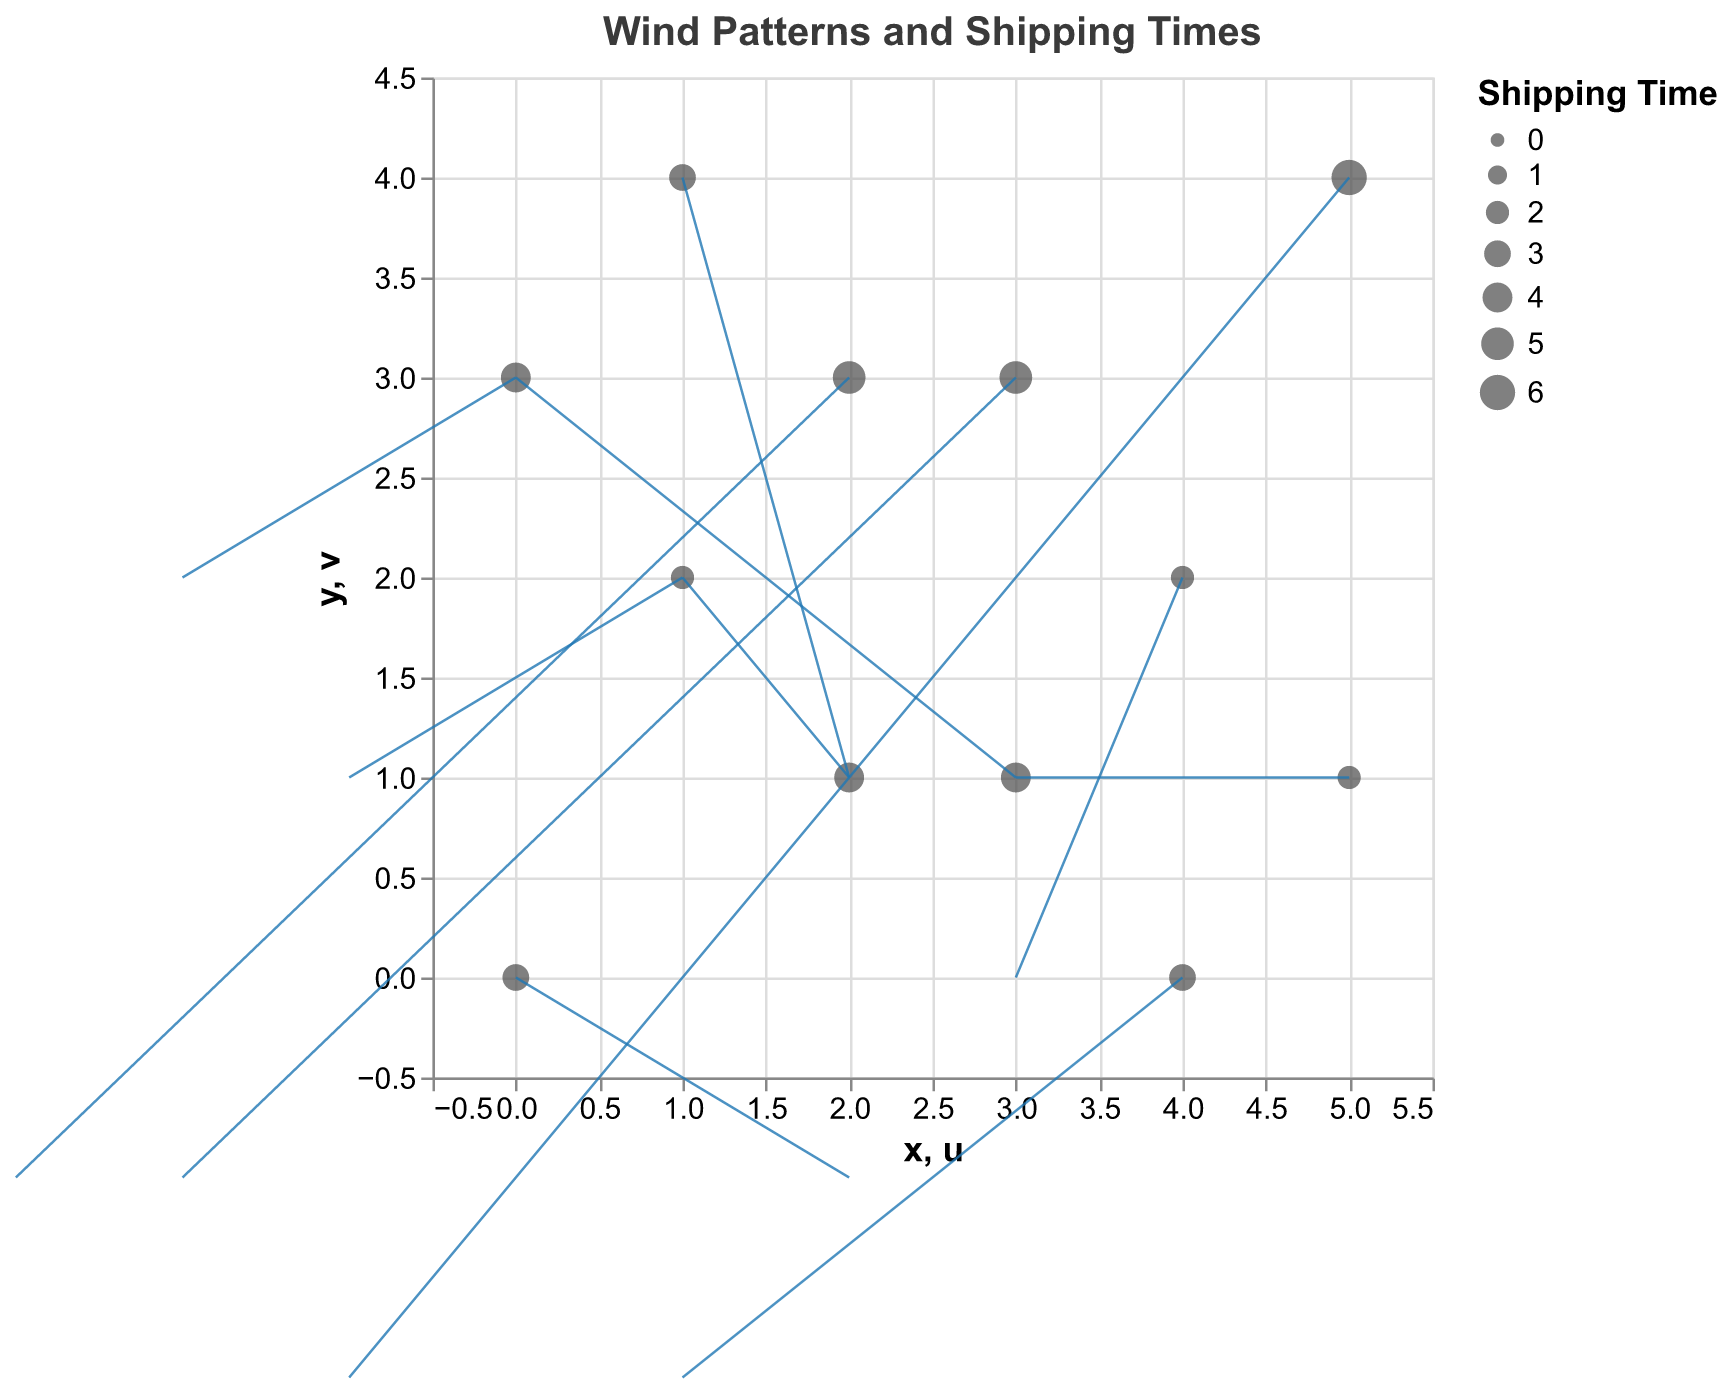How many points are there in the figure? By counting the number of distinct locations represented by dots on the plot, you will see 12 distinct data points.
Answer: 12 What information does the title of the plot provide? The title "Wind Patterns and Shipping Times" indicates that the plot is about the relationship between wind patterns (direction and magnitude of the wind vectors) and shipping times.
Answer: Wind Patterns and Shipping Times Which point has the highest shipping time and what is its value? By observing the size of the dots, the largest dot corresponds to the highest shipping time. The point at (5, 4) has the highest shipping time, which is 6.
Answer: (5, 4) with a value of 6 What is the direction of the wind vector at the point (3, 3)? The direction of the wind vector can be determined by the quiver arrow. At (3, 3), the arrow points in the direction given by (-2, -1), indicating a southwest direction.
Answer: Southwest What is the average shipping time of all the data points in the figure? By summing all shipping times (3 + 2 + 4 + 5 + 2 + 6 + 3 + 4 + 5 + 3 + 4 + 2) and then dividing by the number of points (12), the average shipping time is (43/12).
Answer: 3.58 Which data point has no horizontal movement (u = 0)? By looking at the wind vectors, the point at (3, 1) has no horizontal movement since its u-component is 0.
Answer: (3, 1) Compare the shipping times at points (0, 0) and (5, 1). Which one is higher? By comparing the size of the dots, the shipping time at (0, 0) is 3, and at (5, 1) is 2. Therefore, (0, 0) has the higher shipping time.
Answer: (0, 0) What is the average wind speed magnitude for vectors with positive horizontal components (u > 0)? The points with positive u are (0, 0), (2, 1), (4, 2), (1, 4), (4, 0), and (5, 1). Their magnitudes are √(2² + (-1)²), √(1² + 2²), √(3² + 0²), √(2² + 1²), √(1² + (-2)²), and √(3² + 1²). Calculating, we get √5, √5, 3, √5, √5, and √10. Summing these and dividing by 6 gives the average magnitude.
Answer: 2.33 Which point has the maximum vertical movement (v), and what is its value? The point with the maximum vertical displacement (v component) is (3, 1) with a vertical movement of 3.
Answer: (3, 1) with a value of 3 Does the point with coordinates (2, 3) have a higher shipping time or a longer wind vector magnitude? At (2, 3) the shipping time is 5, and the wind vector magnitude is √((-3)² + (-1)²) = √10 ≈ 3.16. Thus, the shipping time is higher.
Answer: Higher shipping time 